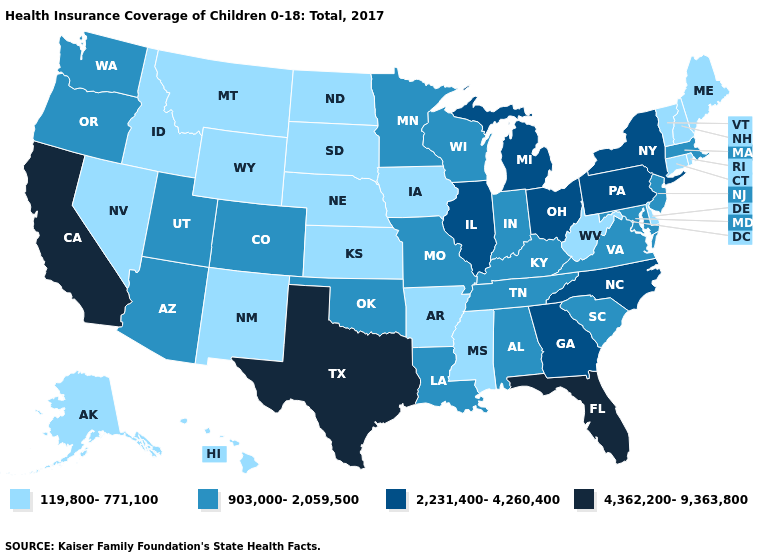What is the value of Wisconsin?
Quick response, please. 903,000-2,059,500. What is the value of Utah?
Be succinct. 903,000-2,059,500. Among the states that border Arkansas , does Tennessee have the highest value?
Short answer required. No. What is the value of Mississippi?
Give a very brief answer. 119,800-771,100. Name the states that have a value in the range 2,231,400-4,260,400?
Be succinct. Georgia, Illinois, Michigan, New York, North Carolina, Ohio, Pennsylvania. Name the states that have a value in the range 2,231,400-4,260,400?
Short answer required. Georgia, Illinois, Michigan, New York, North Carolina, Ohio, Pennsylvania. Does the map have missing data?
Write a very short answer. No. Is the legend a continuous bar?
Quick response, please. No. What is the value of Oklahoma?
Keep it brief. 903,000-2,059,500. How many symbols are there in the legend?
Write a very short answer. 4. Name the states that have a value in the range 2,231,400-4,260,400?
Answer briefly. Georgia, Illinois, Michigan, New York, North Carolina, Ohio, Pennsylvania. Name the states that have a value in the range 2,231,400-4,260,400?
Quick response, please. Georgia, Illinois, Michigan, New York, North Carolina, Ohio, Pennsylvania. Name the states that have a value in the range 119,800-771,100?
Quick response, please. Alaska, Arkansas, Connecticut, Delaware, Hawaii, Idaho, Iowa, Kansas, Maine, Mississippi, Montana, Nebraska, Nevada, New Hampshire, New Mexico, North Dakota, Rhode Island, South Dakota, Vermont, West Virginia, Wyoming. Name the states that have a value in the range 903,000-2,059,500?
Be succinct. Alabama, Arizona, Colorado, Indiana, Kentucky, Louisiana, Maryland, Massachusetts, Minnesota, Missouri, New Jersey, Oklahoma, Oregon, South Carolina, Tennessee, Utah, Virginia, Washington, Wisconsin. Does Virginia have the lowest value in the USA?
Concise answer only. No. 